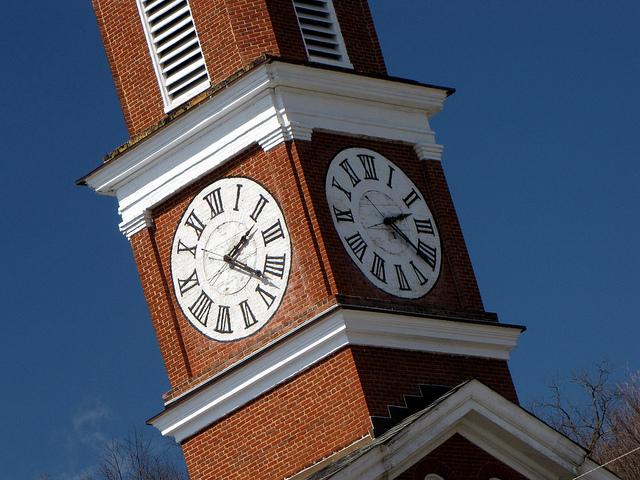How long until midnight?
Quick response, please. 9 hours 37 minutes. What time is it?
Be succinct. 2:23. What is the clock tower made out of?
Answer briefly. Brick. 